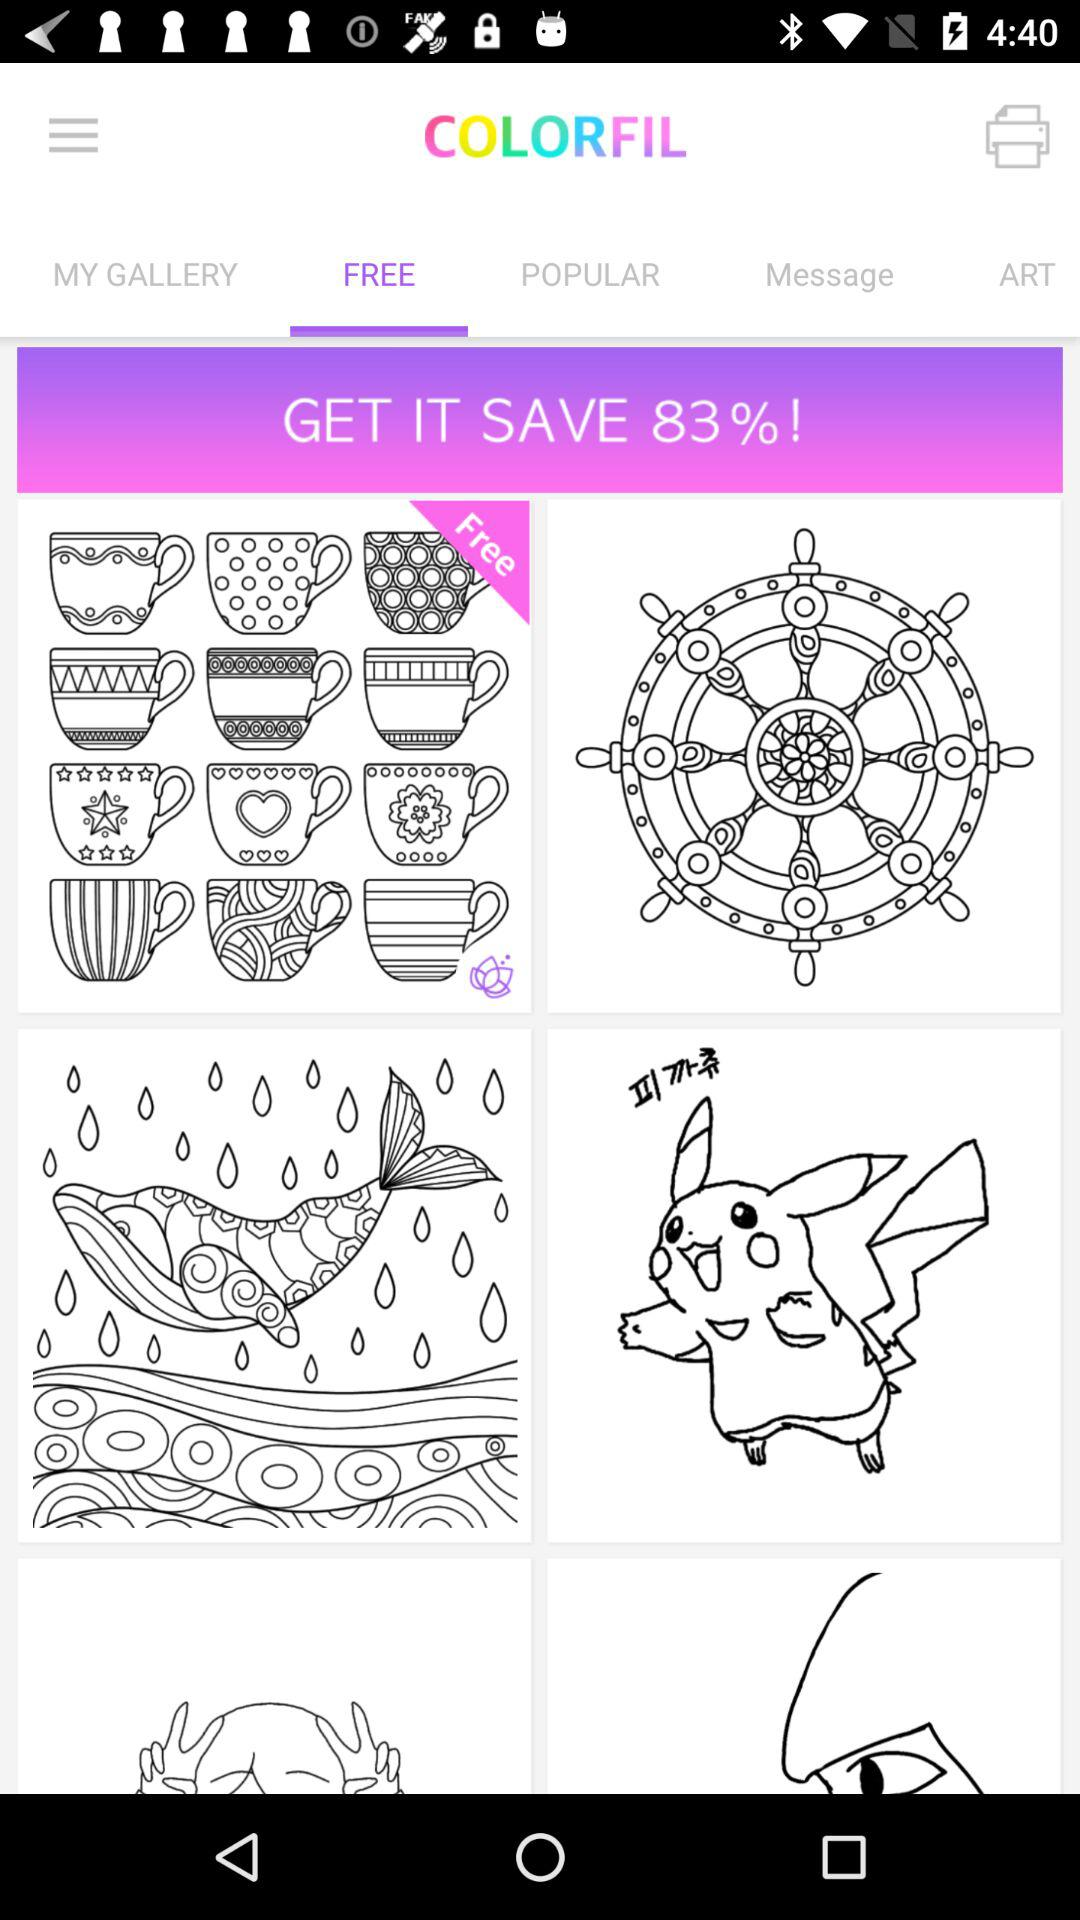What tab is selected? The selected tab is "FREE". 